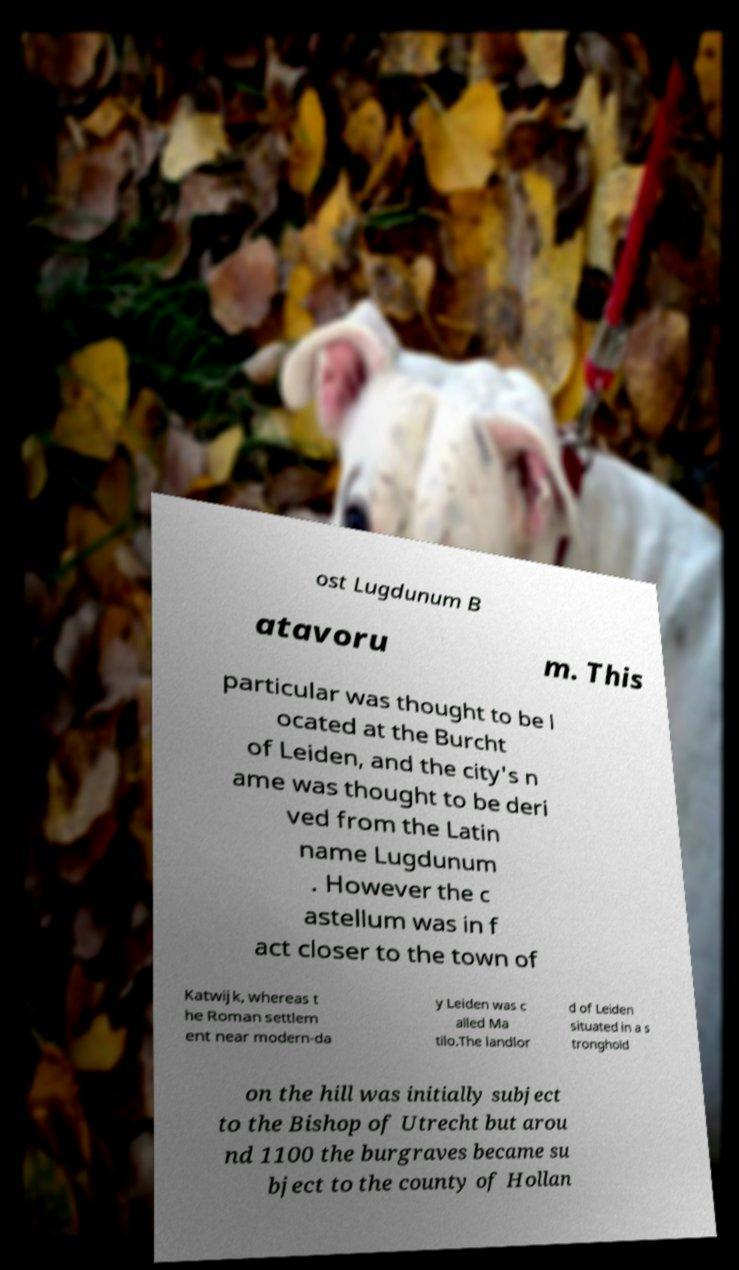What messages or text are displayed in this image? I need them in a readable, typed format. ost Lugdunum B atavoru m. This particular was thought to be l ocated at the Burcht of Leiden, and the city's n ame was thought to be deri ved from the Latin name Lugdunum . However the c astellum was in f act closer to the town of Katwijk, whereas t he Roman settlem ent near modern-da y Leiden was c alled Ma tilo.The landlor d of Leiden situated in a s tronghold on the hill was initially subject to the Bishop of Utrecht but arou nd 1100 the burgraves became su bject to the county of Hollan 